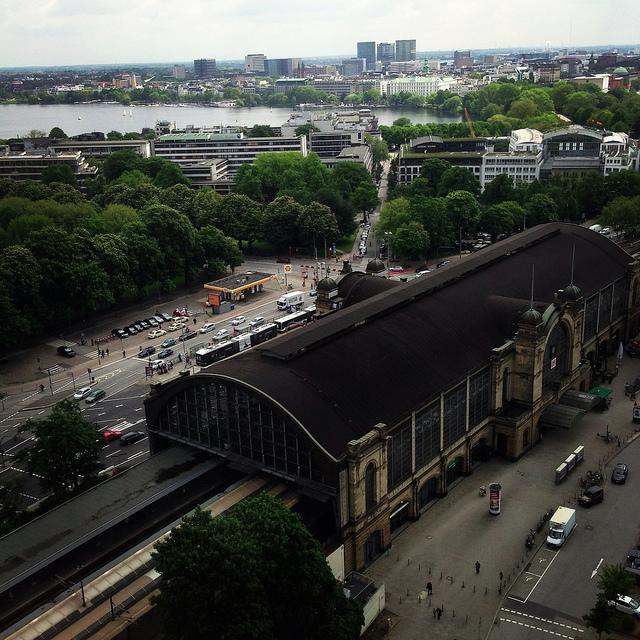The orange rimmed building probable sells which of these products?

Choices:
A) shoes
B) gas
C) flowers
D) televisions gas 